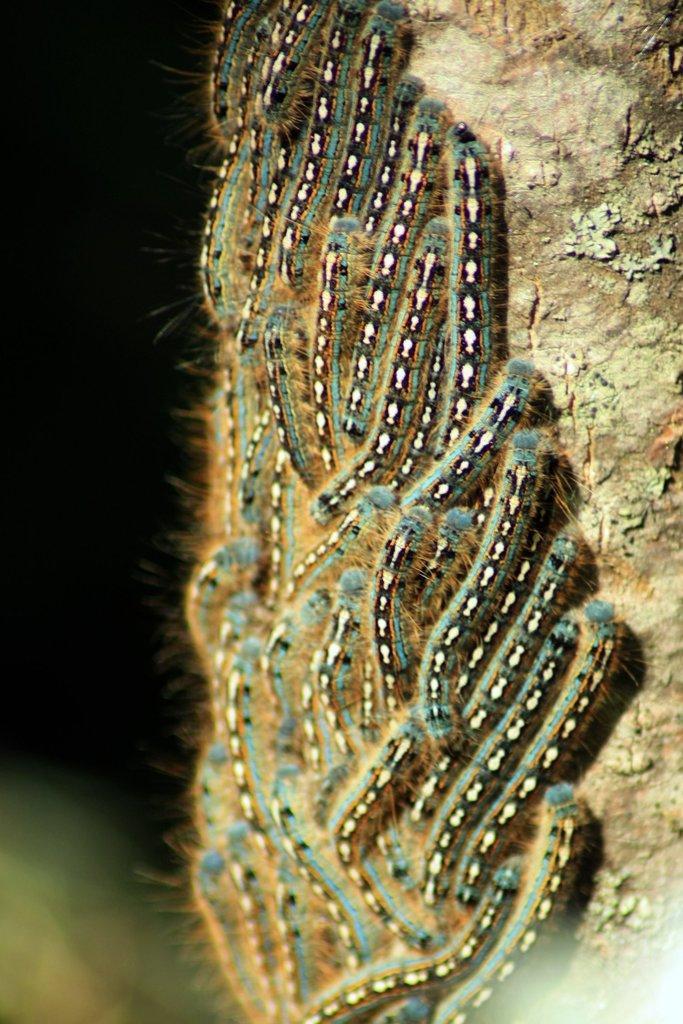How would you summarize this image in a sentence or two? In this picture we can see a group of insects on a wooden surface and in the background it is dark. 